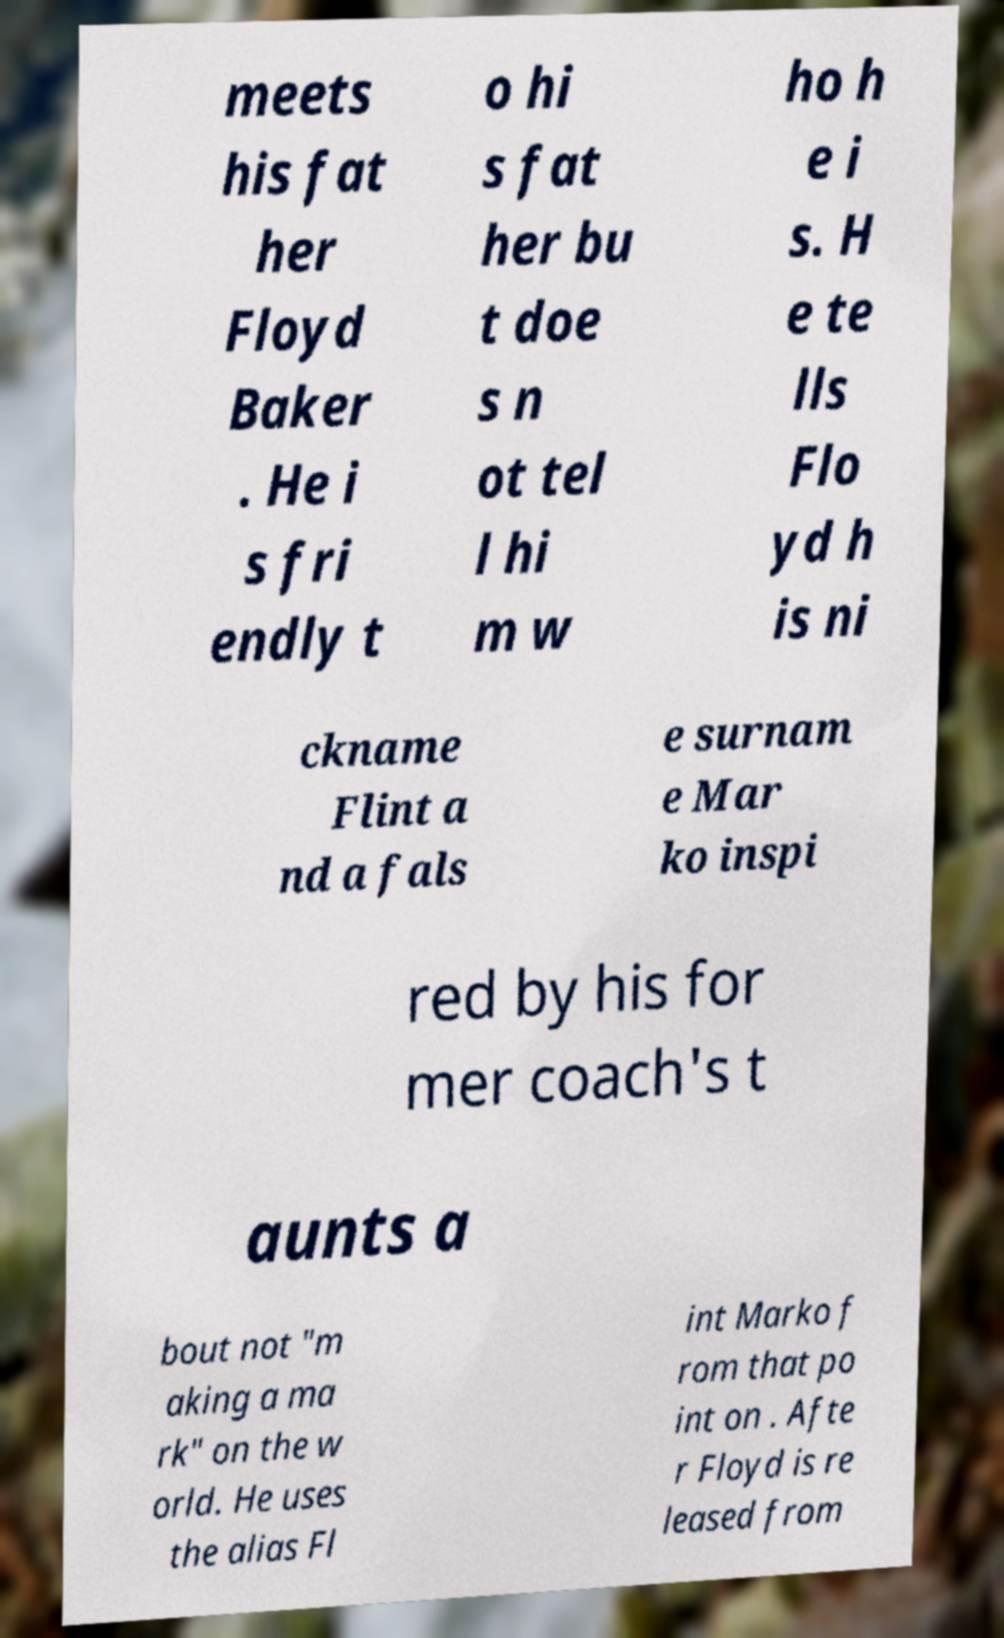There's text embedded in this image that I need extracted. Can you transcribe it verbatim? meets his fat her Floyd Baker . He i s fri endly t o hi s fat her bu t doe s n ot tel l hi m w ho h e i s. H e te lls Flo yd h is ni ckname Flint a nd a fals e surnam e Mar ko inspi red by his for mer coach's t aunts a bout not "m aking a ma rk" on the w orld. He uses the alias Fl int Marko f rom that po int on . Afte r Floyd is re leased from 